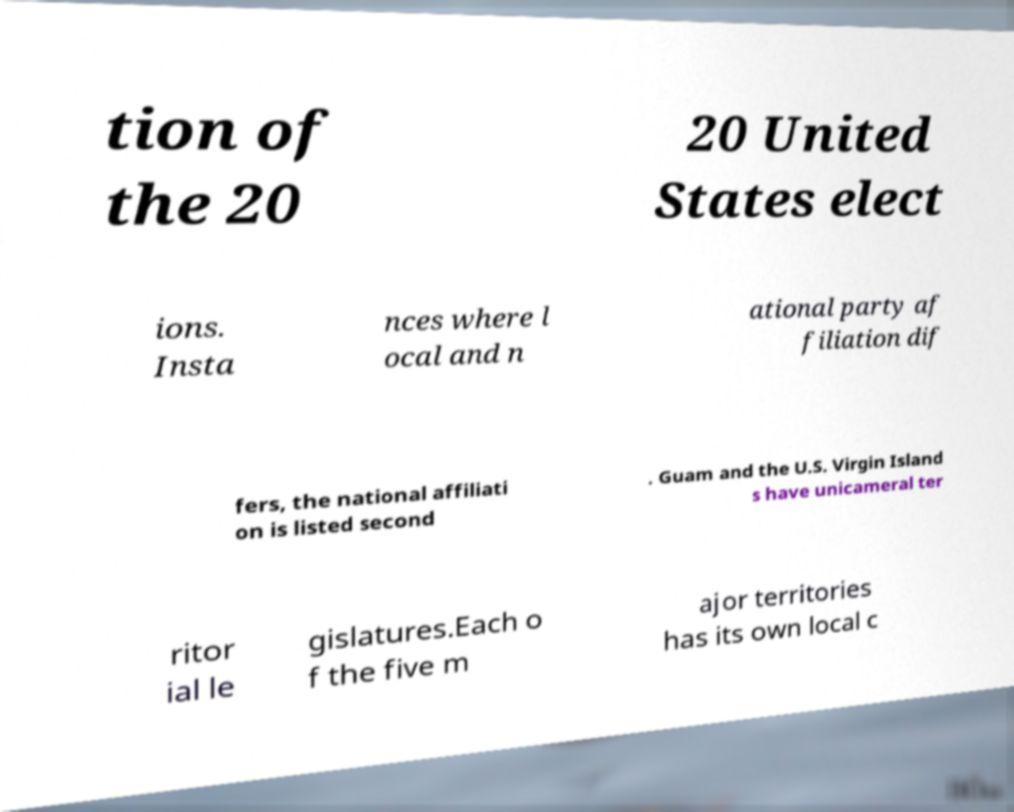What messages or text are displayed in this image? I need them in a readable, typed format. tion of the 20 20 United States elect ions. Insta nces where l ocal and n ational party af filiation dif fers, the national affiliati on is listed second . Guam and the U.S. Virgin Island s have unicameral ter ritor ial le gislatures.Each o f the five m ajor territories has its own local c 